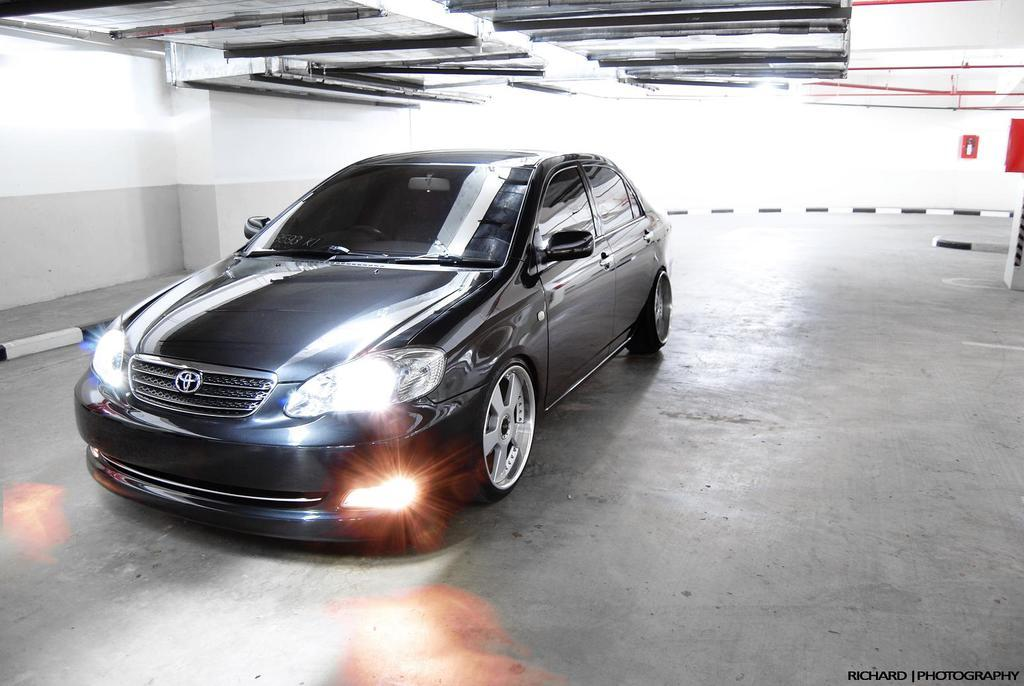What color is the wall in the image? The wall in the image is white. What type of vehicle is present in the image? There is a black color car in the image. Where is the nest of the bird in the image? There is no bird or nest present in the image. What is the car pointing towards in the image? The car is not pointing towards anything in the image, as it is stationary. 